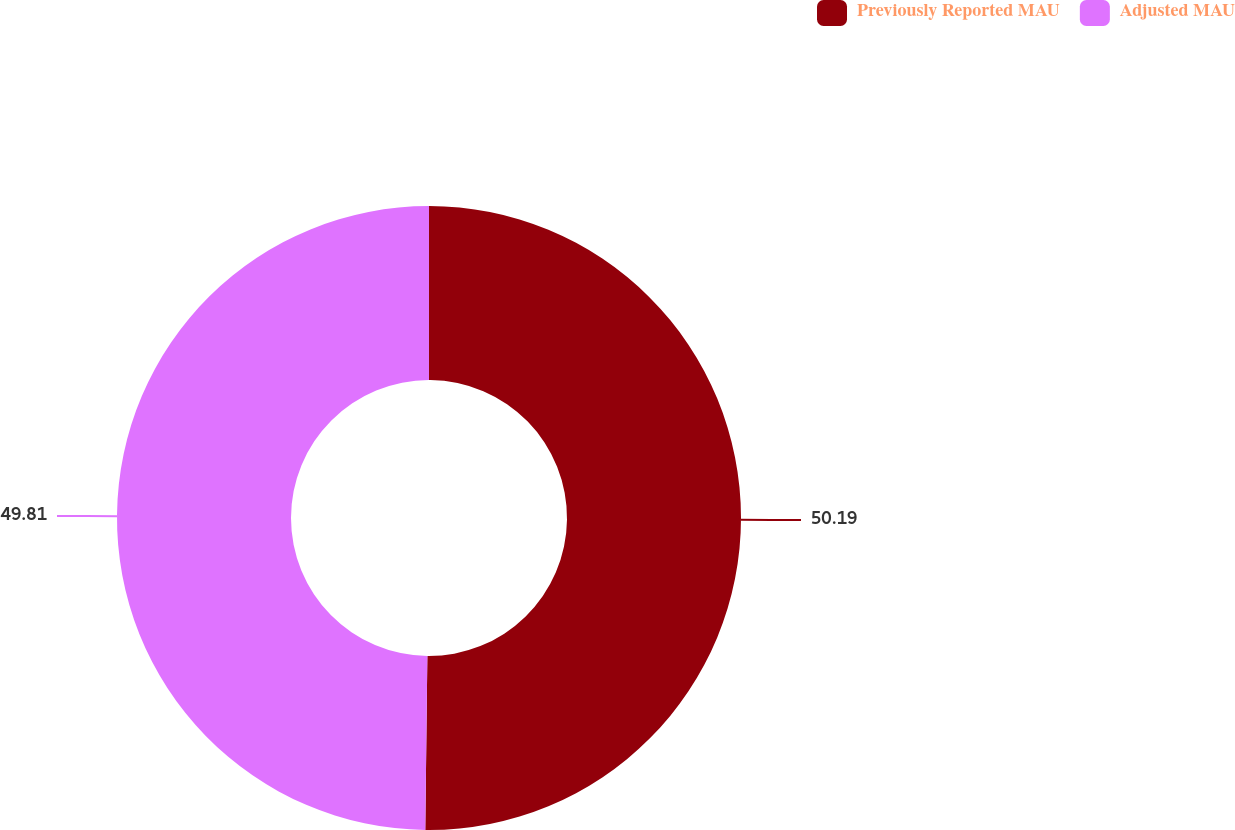Convert chart. <chart><loc_0><loc_0><loc_500><loc_500><pie_chart><fcel>Previously Reported MAU<fcel>Adjusted MAU<nl><fcel>50.19%<fcel>49.81%<nl></chart> 